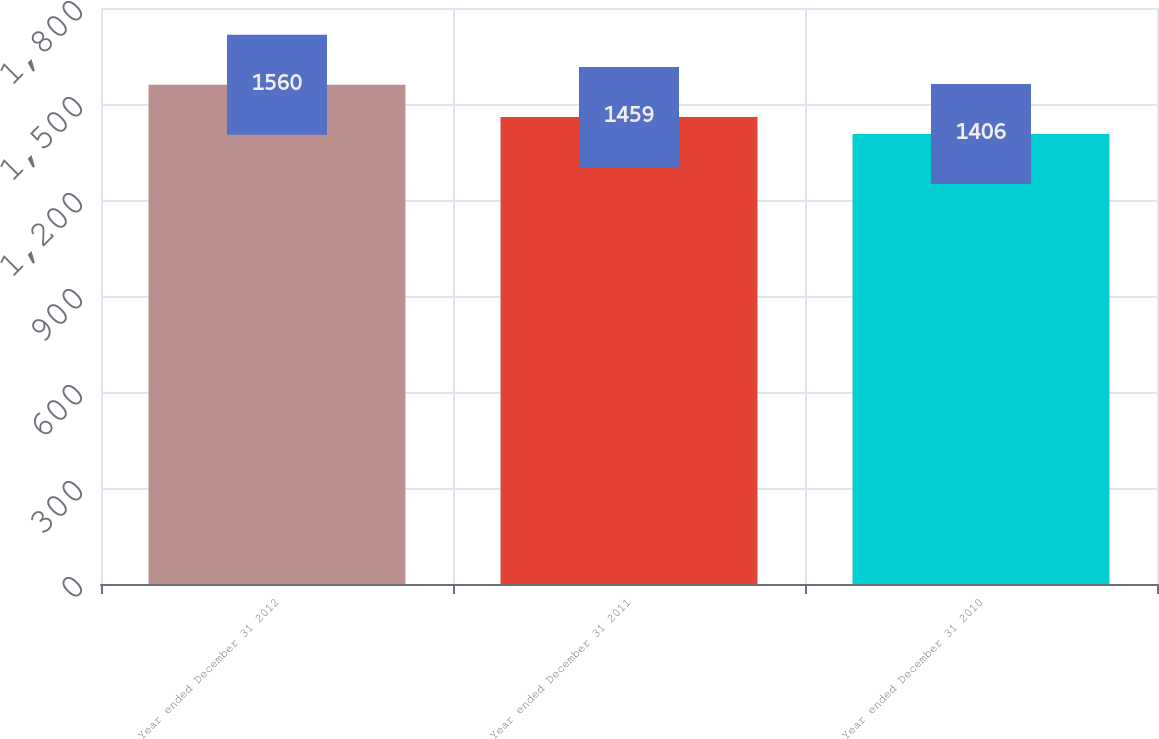Convert chart. <chart><loc_0><loc_0><loc_500><loc_500><bar_chart><fcel>Year ended December 31 2012<fcel>Year ended December 31 2011<fcel>Year ended December 31 2010<nl><fcel>1560<fcel>1459<fcel>1406<nl></chart> 